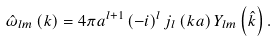Convert formula to latex. <formula><loc_0><loc_0><loc_500><loc_500>\hat { \omega } _ { l m } \left ( k \right ) = 4 \pi a ^ { l + 1 } \left ( - i \right ) ^ { l } j _ { l } \left ( k a \right ) Y _ { l m } \left ( \hat { k } \right ) .</formula> 